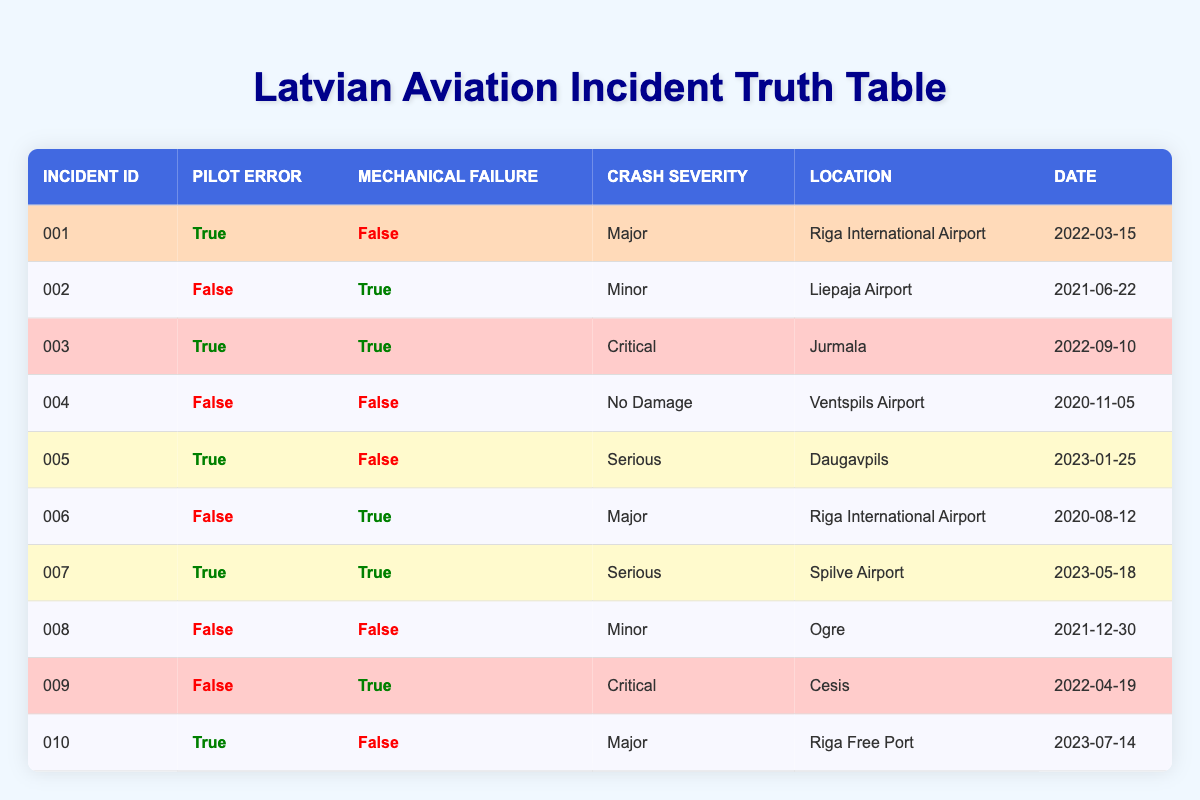What is the incident ID of the crash that involved pilot error but no mechanical failure? Looking at the table, I find that the crashes with pilot error and no mechanical failure include incident IDs 001, 005, and 010. Thus, one example is incident ID 001.
Answer: 001 How many incidents involved both pilot error and mechanical failure? By reviewing the table, I see that there are two incidents where both pilot error and mechanical failure occurred: incident IDs 003 and 007. Therefore, the count is 2.
Answer: 2 What is the crash severity of the incident that occurred at Riga Free Port? The table indicates that the incident at Riga Free Port, which is incident ID 010, has a crash severity of "Major."
Answer: Major Did any incidents result in "No Damage"? Referring to the table, incident ID 004 clearly states that it resulted in "No Damage." Hence the answer is yes.
Answer: Yes What is the ratio of incidents with pilot error to those with mechanical failure? Counting the total incidents, there are 5 incidents with pilot error (001, 003, 005, 007, 010) and 4 incidents with mechanical failure (002, 006, 003, 009). Therefore, the ratio of pilot error incidents to mechanical failure incidents is 5:4.
Answer: 5:4 Which location had the most severe crash and what was the severity level? Analyzing the table, the most severe crash is listed as incident ID 003 which occurred in Jurmala and is marked as "Critical."
Answer: Jurmala, Critical How many incidents were classified as "Major"? After reviewing the table, the incidents classified as "Major" are incident IDs 001, 006, and 010. This gives us a total of 3 "Major" incidents.
Answer: 3 Is there any incident with both pilot error and a crash severity of "Minor"? Upon checking the table, I find that there are no incidents listed that have both pilot error and a crash severity of "Minor," so the answer is no.
Answer: No What percentage of incidents had no mechanical failure? There are 10 total incidents, and 5 of them (001, 004, 005, 008, 010) had no mechanical failure. Therefore, the percentage is (5/10) * 100 = 50%.
Answer: 50% 